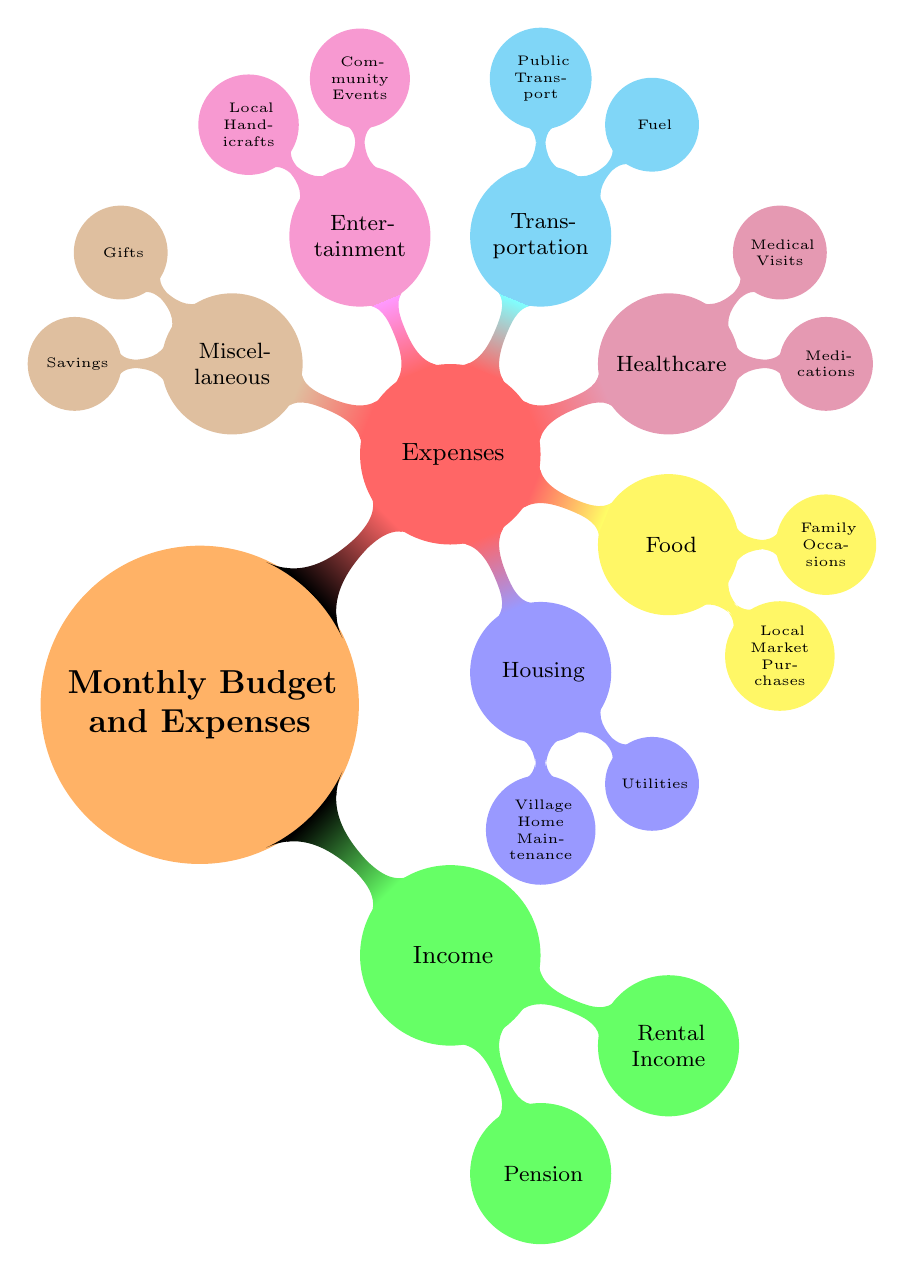What are the two sources of income listed in the diagram? The diagram lists two sources of income directly under the "Income" section: "Pension" and "Rental Income".
Answer: Pension, Rental Income How many categories of expenses are shown in the diagram? The diagram displays six categories under the "Expenses" section: Housing, Food, Healthcare, Transportation, Entertainment, and Miscellaneous. Thus, the total is six categories.
Answer: 6 What type of medical costs are included in healthcare expenses? Under the "Healthcare" category, the diagram highlights two specific types of medical costs: "Medications" and "Medical Visits".
Answer: Medications, Medical Visits Which category does "Community Events" belong to? "Community Events" is located under the "Entertainment" section of the expenses. This connection indicates that it falls within social activities allocated for enjoyment.
Answer: Entertainment What type of service does "Public Transport" refer to in the diagram? "Public Transport" is categorized under "Transportation," indicating that it refers to bus and taxi costs for getting around, a form of transportation expense.
Answer: Transportation Which expense category has a subcategory for fuel? The subcategory for fuel can be found within the "Transportation" category. This shows that the expense related to fuel is specifically classified under transportation costs.
Answer: Transportation What subcategory relates to family events in the Food expenses? Within the "Food" expenses, the subcategory that relates to family events is "Dining Out", which is specifically noted for family occasions at cafes.
Answer: Dining Out How is "Savings" classified in the diagram? In the diagram, "Savings" is categorized under "Miscellaneous" expenses, indicating it's classified as a non-specific financial cushion for emergencies.
Answer: Miscellaneous 